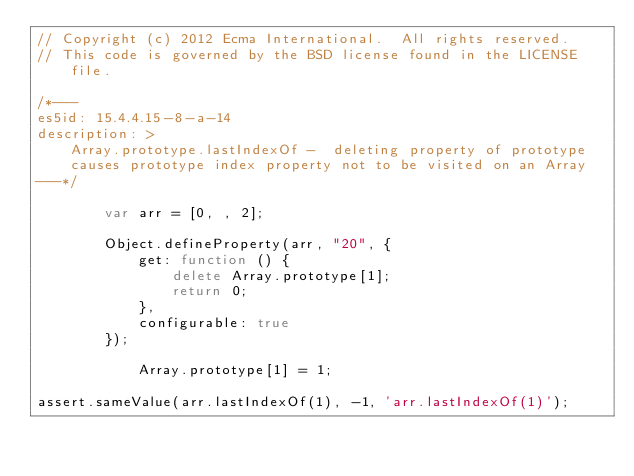Convert code to text. <code><loc_0><loc_0><loc_500><loc_500><_JavaScript_>// Copyright (c) 2012 Ecma International.  All rights reserved.
// This code is governed by the BSD license found in the LICENSE file.

/*---
es5id: 15.4.4.15-8-a-14
description: >
    Array.prototype.lastIndexOf -  deleting property of prototype
    causes prototype index property not to be visited on an Array
---*/

        var arr = [0, , 2];

        Object.defineProperty(arr, "20", {
            get: function () {
                delete Array.prototype[1];
                return 0;
            },
            configurable: true
        });

            Array.prototype[1] = 1;

assert.sameValue(arr.lastIndexOf(1), -1, 'arr.lastIndexOf(1)');
</code> 